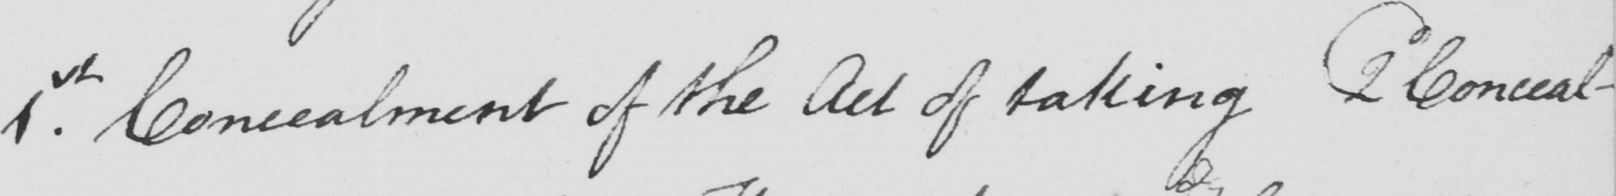What is written in this line of handwriting? 1st . Concealment of the Act of taking 2d Conceal- 